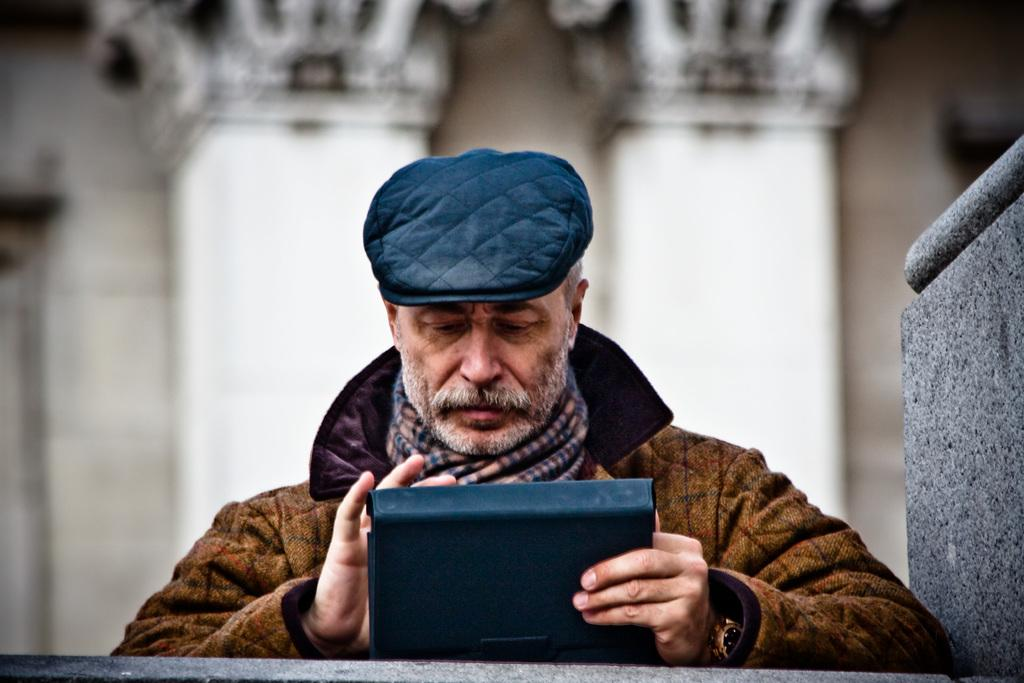What is the main subject of the image? The main subject of the image is a man. What is the man wearing on his head? The man is wearing a cap. What type of clothing is the man wearing on his upper body? The man is wearing a jacket. What is the man holding in his hand? The man is holding an object in his hand. What is the man's focus in the image? The man is staring at something. How many giants can be seen in the image? There are no giants present in the image. What is the man laughing at in the image? The man is not laughing in the image; he is staring at something. 